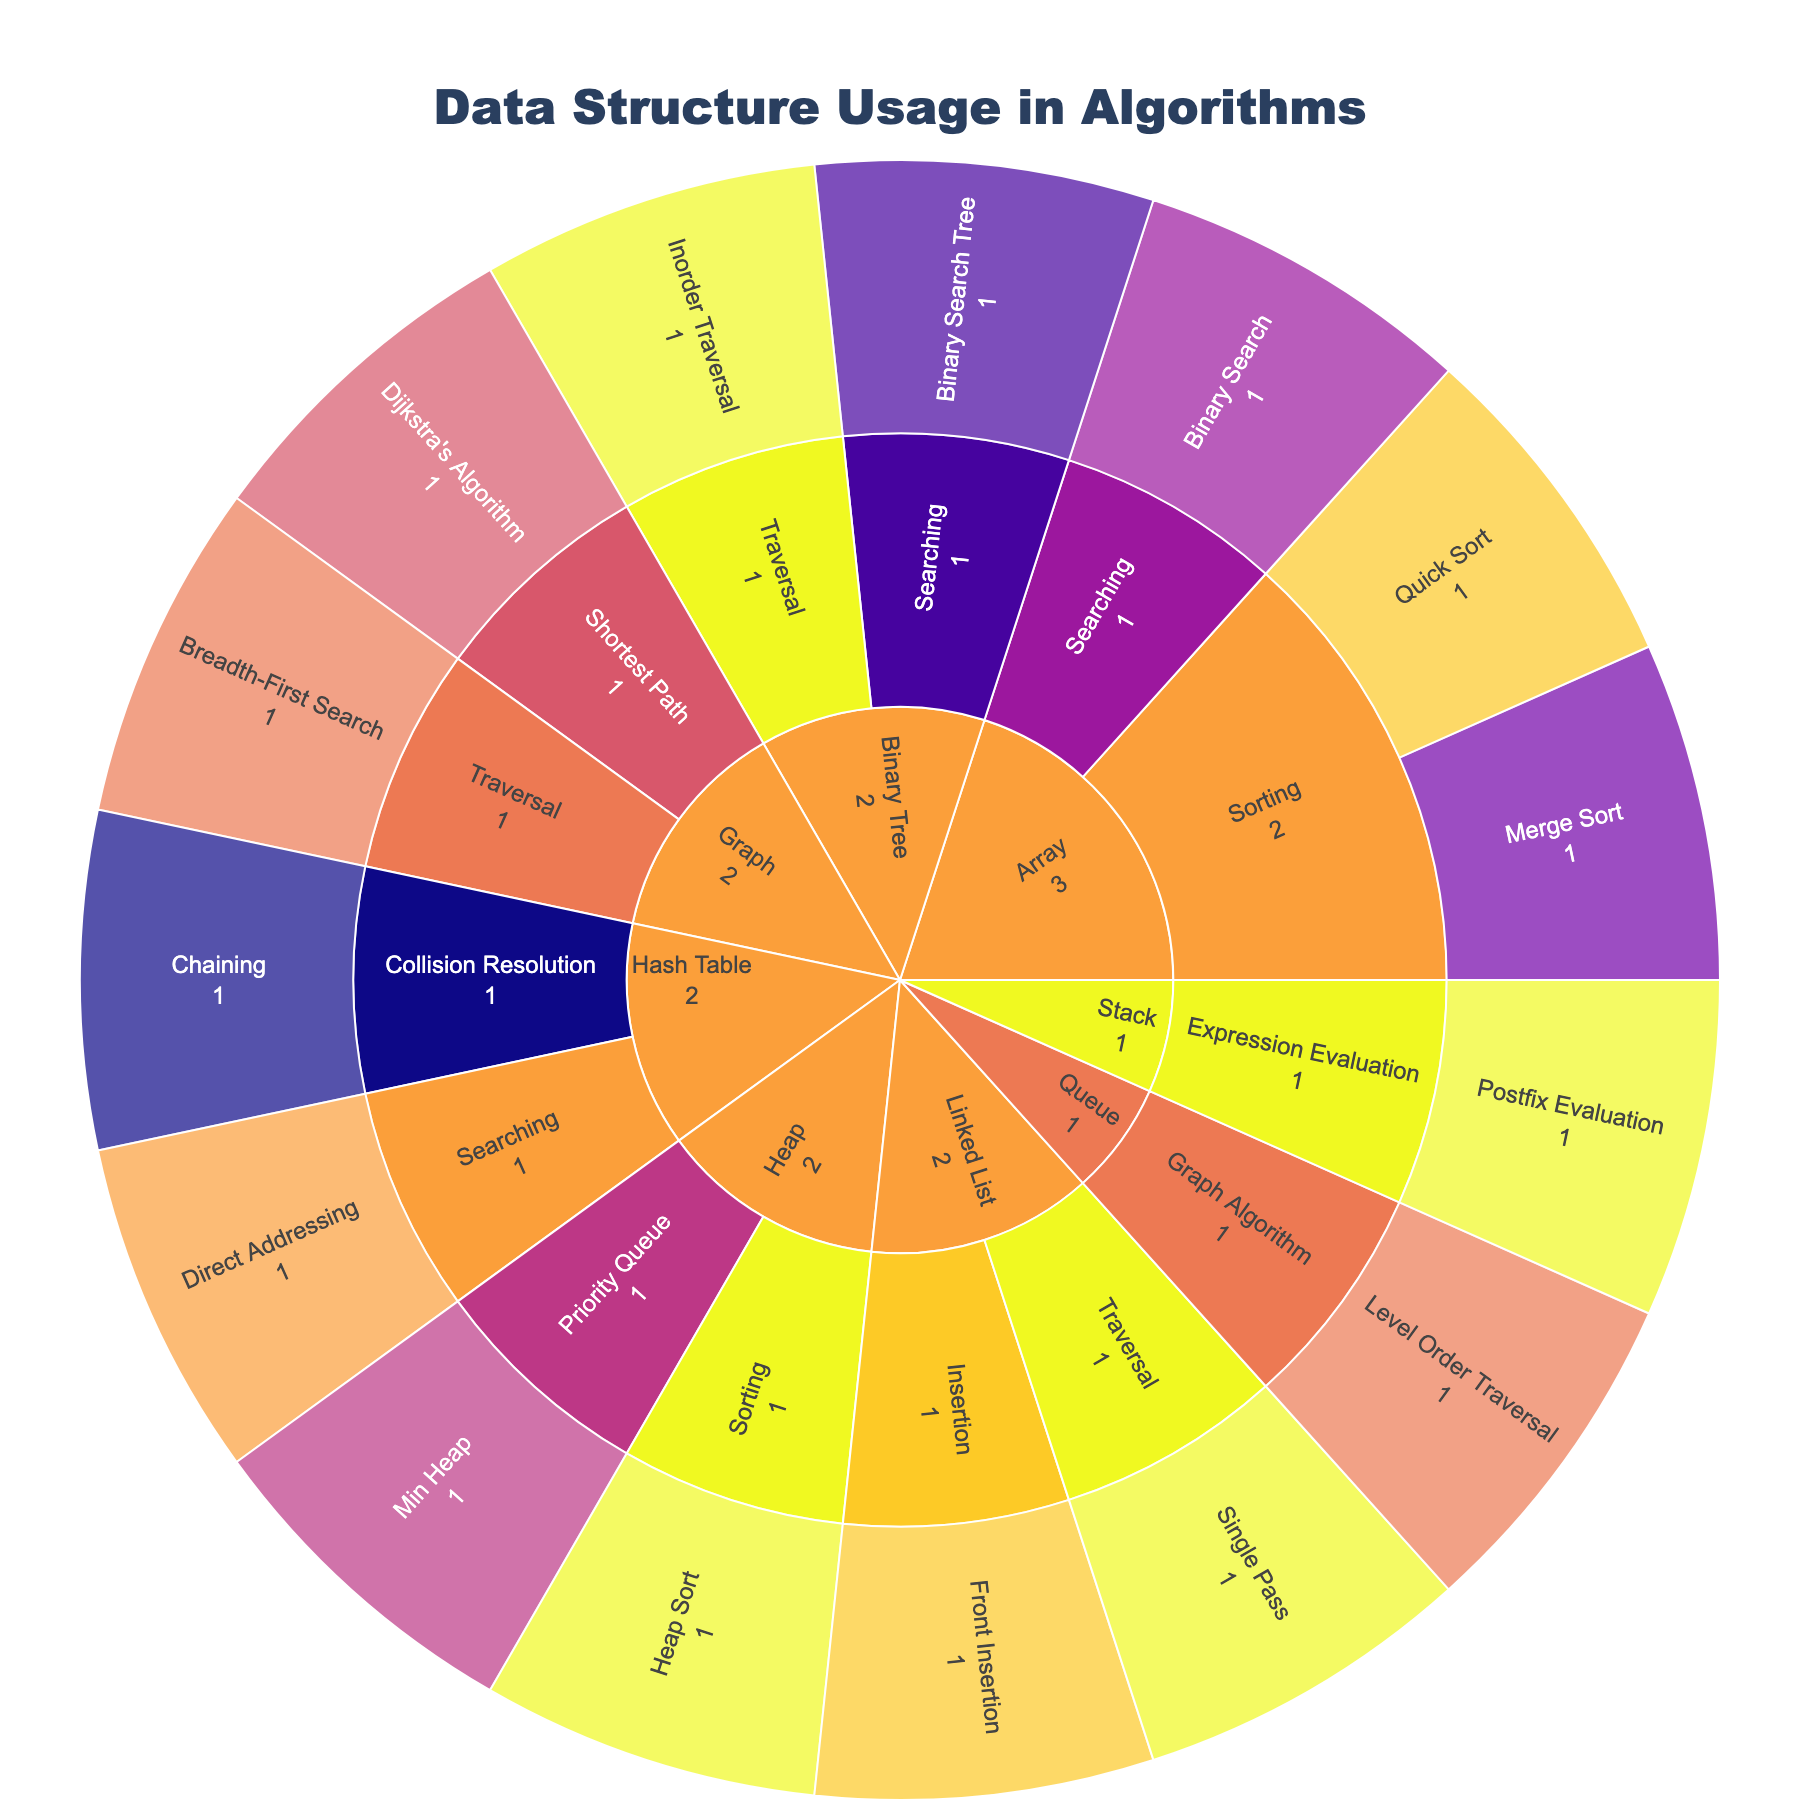What are the data structures used in the algorithms shown in the figure? The data structures used can be identified by looking at the different segments of the outermost layer of the sunburst plot. Each segment represents a distinct data structure. These include Array, Linked List, Hash Table, Binary Tree, Heap, Graph, Stack, and Queue.
Answer: Array, Linked List, Hash Table, Binary Tree, Heap, Graph, Stack, Queue Which algorithm types are associated with the Binary Tree data structure? To find the algorithm types related to the Binary Tree, locate the Binary Tree segment and look at the subdivisions within that segment. These subdivisions indicate the algorithm types. In this case, the Binary Tree data structure has Traversal and Searching algorithm types.
Answer: Traversal, Searching What is the performance implication of Quick Sort using an Array? The performance implication is shown when you drill down from the outermost 'Array' segment to the 'Sorting' segment and then to 'Quick Sort'. It displays 'O(n log n) average case' as the performance implication.
Answer: O(n log n) average case How does the time complexity of Binary Search compare to Direct Addressing in a Hash Table? To compare the time complexities, examine the performance implications noted for both Binary Search and Direct Addressing. Binary Search under the Array -> Searching branch shows 'O(log n) time complexity'. Direct Addressing under Hash Table -> Searching shows 'O(1) average case lookup'. Comparing these, Direct Addressing has a constant time complexity, which is more efficient than Binary Search's logarithmic time complexity.
Answer: O(log n) vs. O(1) What is the most common performance implication among the algorithms in the figure? By observing the color coding associated with performance implications across all segments, the most frequent implication can be identified. Upon close inspection, 'O(n) time complexity' appears to be the most common, noticeable in various segments like Linked List -> Traversal, Binary Tree -> Traversal, Stack -> Expression Evaluation, etc.
Answer: O(n) time complexity Which algorithms have a performance implication of O(n log n)? To identify these algorithms, follow the color-coded performance segments labeled 'O(n log n)' and see which specific algorithms they correspond to. Quick Sort (Array -> Sorting), Merge Sort (Array -> Sorting), and Heap Sort (Heap -> Sorting) all exhibit 'O(n log n)' performance implications.
Answer: Quick Sort, Merge Sort, Heap Sort How many specific algorithms are associated with the Graph data structure category? To determine this, locate the Graph data structure segment and count the total number of subdivisions under it, representing specific algorithms. There are two segments: Breadth-First Search and Dijkstra's Algorithm.
Answer: 2 Does the Queue data structure feature any algorithms with the same performance as Breadth-First Search in Graphs? Both have performance implications annotated in the same color. Comparing their performance implications, Breadth-First Search under Graph shows 'O(V + E) time complexity', and Level Order Traversal under Queue -> Graph Algorithm also has 'O(V + E) time complexity'. Thus, they have identical performance.
Answer: Yes Which data structure allows O(1) average case lookup for searching operations? To find this, locate the segments associated with search operations across various data structures and identify which ones have the 'O(1) average case lookup'. The Hash Table -> Searching -> Direct Addressing segment has this performance implication.
Answer: Hash Table 